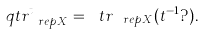<formula> <loc_0><loc_0><loc_500><loc_500>\ q t r ^ { t } _ { \ r e p X } = \ t r _ { \ r e p X } ( t ^ { - 1 } ? ) .</formula> 